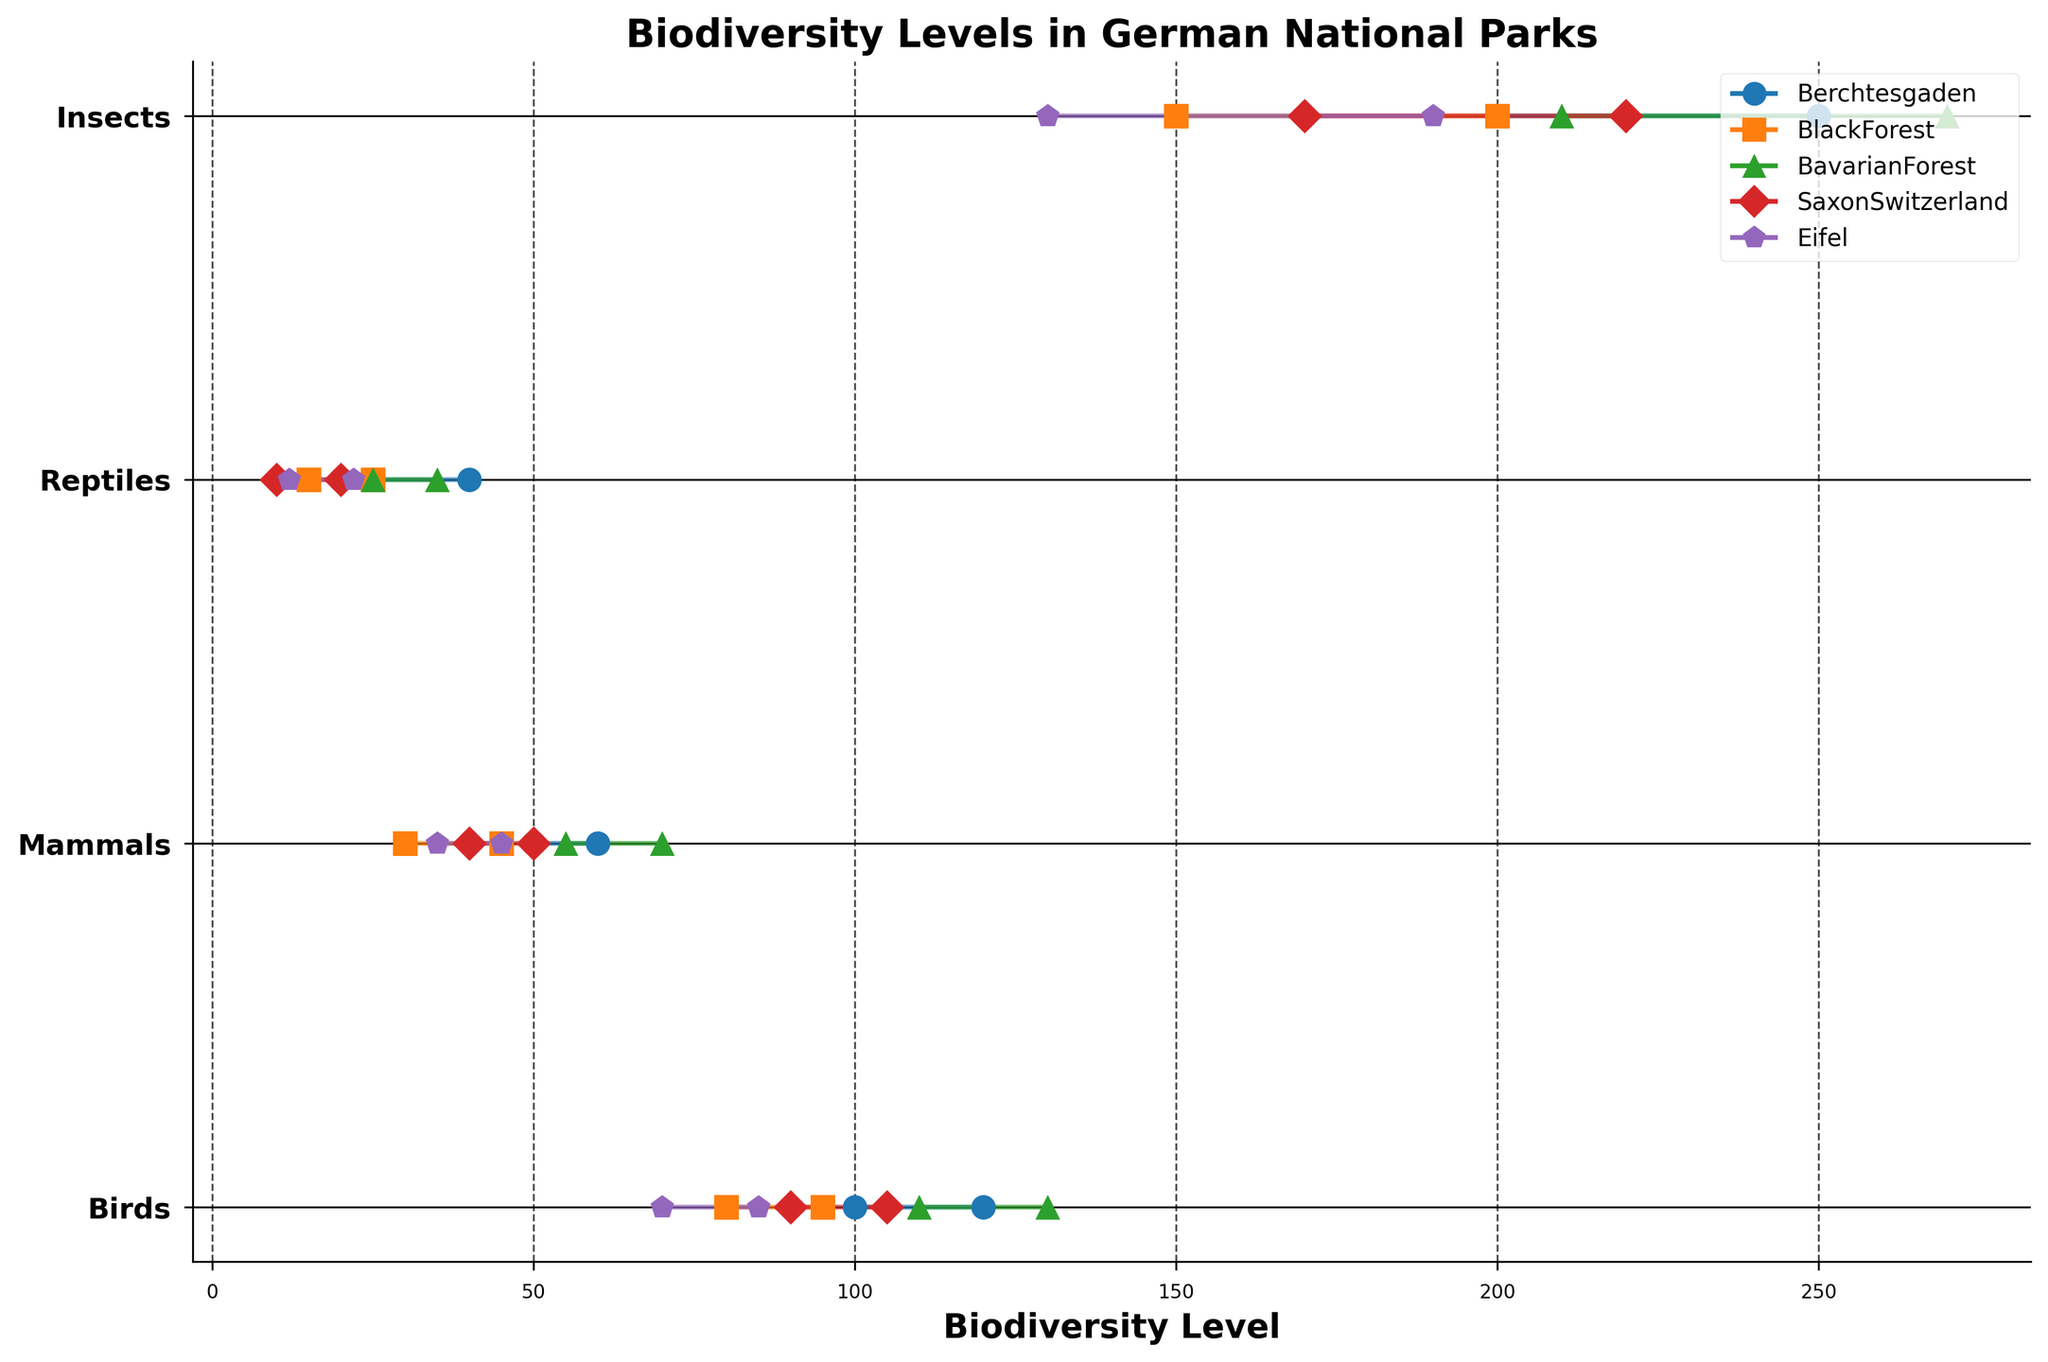Which national park has the highest maximum biodiversity level for insects? By examining the maximum biodiversity levels for insects in each national park, we can see that Bavarian Forest has the highest maximum value of 270.
Answer: Bavarian Forest Which species type in Berchtesgaden has the smallest range of biodiversity levels? In Berchtesgaden, the range for Birds is 20 (120-100), for Mammals is 10 (60-50), for Reptiles is 20 (40-20), and for Insects is 50 (250-200). The smallest range is for Mammals.
Answer: Mammals How does the maximum biodiversity level of Mammals in Black Forest compare to that in Saxon Switzerland? The maximum biodiversity level for Mammals in Black Forest is 45, while in Saxon Switzerland it is 50. Therefore, the level in Saxon Switzerland is higher.
Answer: Saxon Switzerland has higher What is the range of biodiversity levels for Reptiles in all the parks? The ranges for Reptiles in each park are Berchtesgaden: (40-20 = 20), Black Forest: (25-15 = 10), Bavarian Forest: (35-25 = 10), Saxon Switzerland: (20-10 = 10), and Eifel: (22-12 = 10).
Answer: 10-20 Which park has the lowest minimum biodiversity level for Birds? The minimum values for Birds in each park are Berchtesgaden: 100, Black Forest: 80, Bavarian Forest: 110, Saxon Switzerland: 90, and Eifel: 70. The lowest minimum value is 70 in Eifel.
Answer: Eifel If you average the maximum biodiversity levels of Reptiles across all parks, what do you get? Adding the maximum biodiversity levels for Reptiles across the parks (Berchtesgaden: 40, Black Forest: 25, Bavarian Forest: 35, Saxon Switzerland: 20, Eifel: 22) gives 40+25+35+20+22 = 142, and dividing by 5 parks, the average is 142/5 = 28.4.
Answer: 28.4 Which species type in Saxon Switzerland has the largest range of biodiversity levels? The ranges for each species type in Saxon Switzerland are Birds: 15 (105-90), Mammals: 10 (50-40), Reptiles: 10 (20-10), and Insects: 50 (220-170). The largest range is 50 for Insects.
Answer: Insects Compare the minimum biodiversity levels for Insects in Bavarian Forest and Eifel. Which one is higher? The minimum biodiversity level for Insects in Bavarian Forest is 210, while in Eifel it is 130. Therefore, the minimum level in Bavarian Forest is higher.
Answer: Bavarian Forest What is the total range of biodiversity levels for Mammals across all parks? The ranges of biodiversity levels for Mammals in the parks are: Berchtesgaden: (60-50 = 10), Black Forest: (45-30 = 15), Bavarian Forest: (70-55 = 15), Saxon Switzerland: (50-40 = 10), and Eifel: (45-35 = 10). Summing them up results in 10+15+15+10+10 = 60.
Answer: 60 Which national park has the closest minimum and maximum biodiversity levels for Birds? The ranges for Birds in each park are calculated as Berchtesgaden: 20 (120-100), Black Forest: 15 (95-80), Bavarian Forest: 20 (130-110), Saxon Switzerland: 15 (105-90), and Eifel: 15 (85-70). The parks with the closest minimum and maximum biodiversity levels are Black Forest, Saxon Switzerland, and Eifel with a range of 15 each.
Answer: Black Forest, Saxon Switzerland, and Eifel 